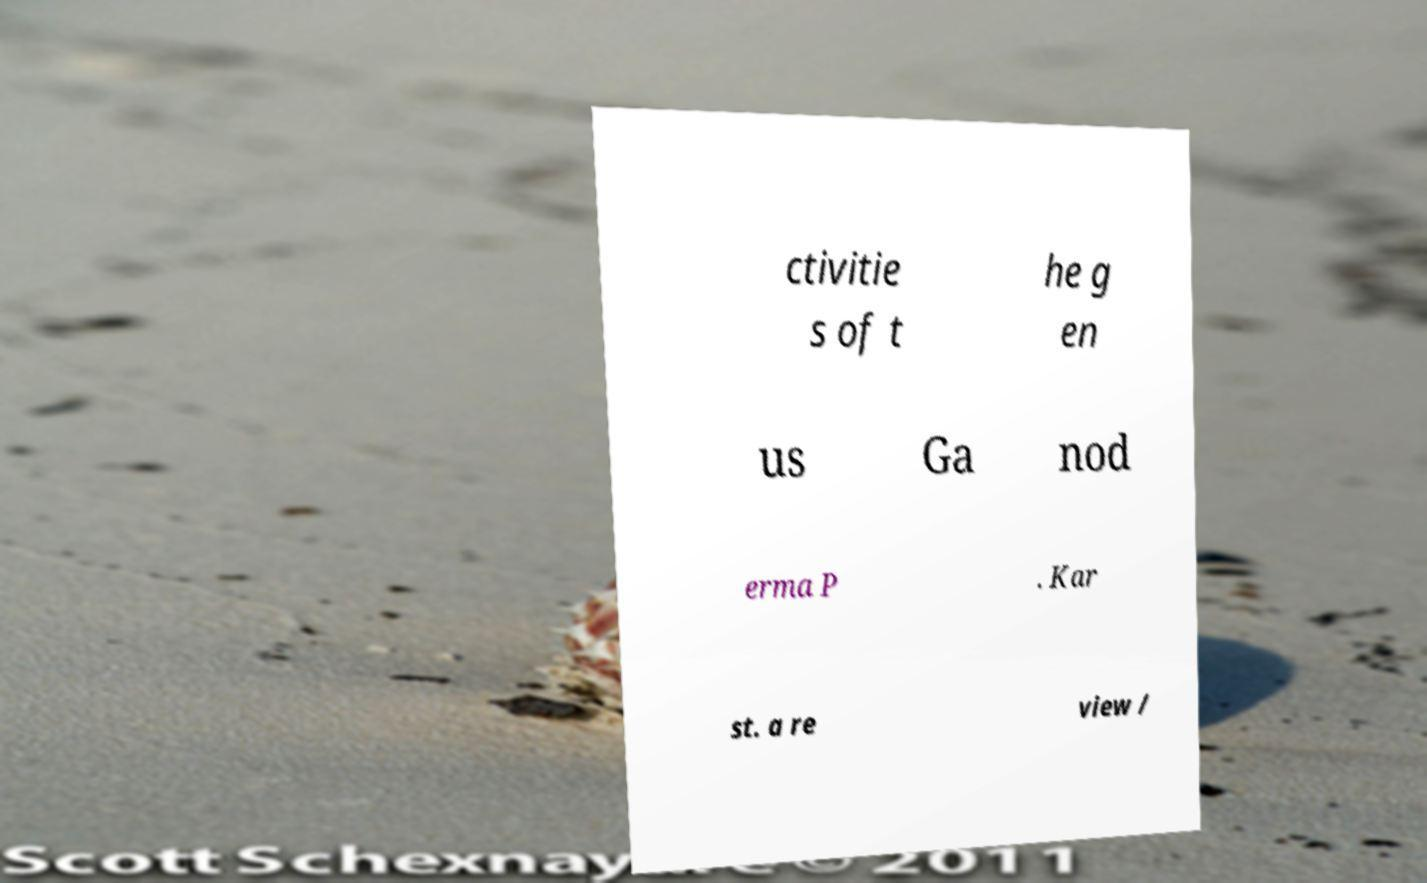What messages or text are displayed in this image? I need them in a readable, typed format. ctivitie s of t he g en us Ga nod erma P . Kar st. a re view / 